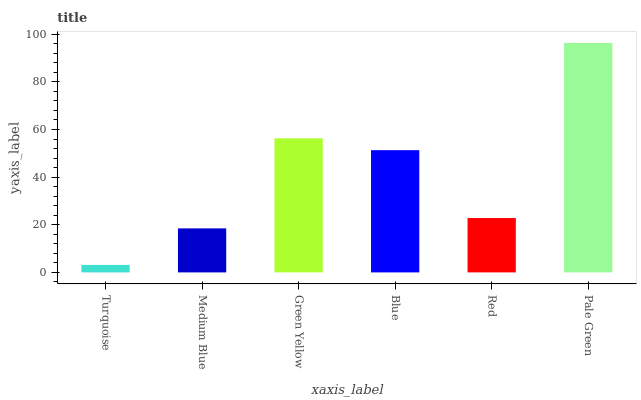Is Medium Blue the minimum?
Answer yes or no. No. Is Medium Blue the maximum?
Answer yes or no. No. Is Medium Blue greater than Turquoise?
Answer yes or no. Yes. Is Turquoise less than Medium Blue?
Answer yes or no. Yes. Is Turquoise greater than Medium Blue?
Answer yes or no. No. Is Medium Blue less than Turquoise?
Answer yes or no. No. Is Blue the high median?
Answer yes or no. Yes. Is Red the low median?
Answer yes or no. Yes. Is Green Yellow the high median?
Answer yes or no. No. Is Turquoise the low median?
Answer yes or no. No. 